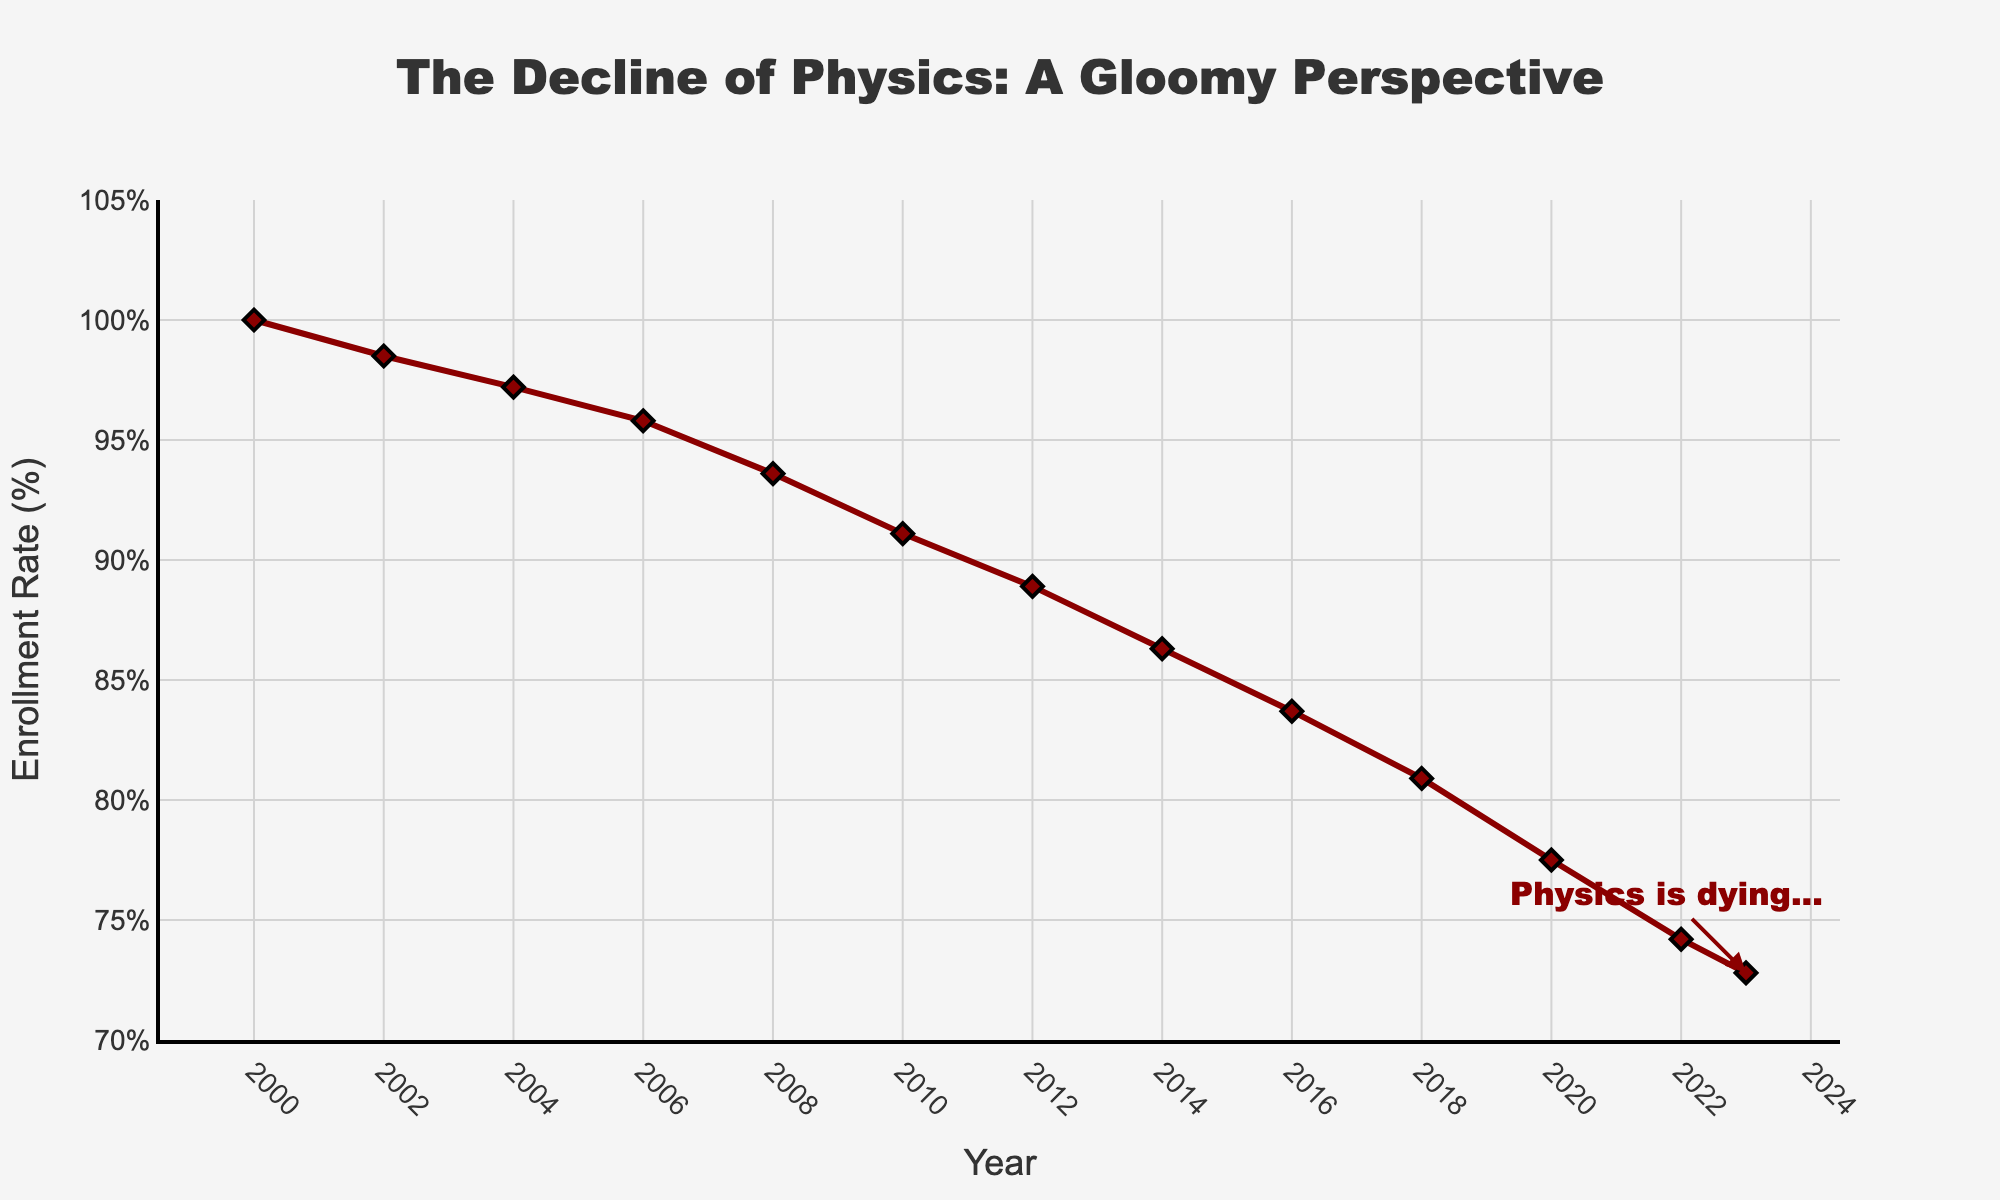What was the enrollment rate in 2000 compared to 2023? The enrollment rate in 2000 can be located at the beginning of the plotted line, while the rate for 2023 is at the end. Simply compare these two values on the y-axis. The enrollment rate was 100% in 2000 and dropped to 72.8% in 2023.
Answer: 100% vs 72.8% By how much did the enrollment rate decrease from 2008 to 2010? Locate the points for the years 2008 and 2010 on the x-axis, then see the corresponding y-values. The enrollment rates were 93.6% in 2008 and 91.1% in 2010. Subtract these values to find the decrease. 93.6% - 91.1% = 2.5%.
Answer: 2.5% Which year had the steepest year-over-year decline in enrollment rate? Examine the slope between consecutive years in the chart and identify the steepest part of the line. The steepest decline appears to be between 2020 and 2022, where enrollment drops from 77.5% to 74.2%. Calculate the difference to confirm. 77.5% - 74.2% = 3.3%.
Answer: 2020-2022 What is the overall percentage decrease in enrollment from 2000 to 2023? Subtract the enrollment rate in 2023 from that in 2000, then divide by the 2000 rate, and multiply by 100 to get the percentage decrease. (100% - 72.8%) / 100% * 100 = 27.2%.
Answer: 27.2% How does the enrollment rate in 2023 compare to the average enrollment rate from 2000 to 2023? Calculate the average enrollment rate over all the given years, then compare it to the 2023 rate. To find the average: (Sum of all annual rates from 2000 to 2023) / 13 = (100 + 98.5 + 97.2 + 95.8 + 93.6 + 91.1 + 88.9 + 86.3 + 83.7 + 80.9 + 77.5 + 74.2 + 72.8) / 13 ≈ 88.0%.
Answer: Lower Which year marks the start of the most consistent decrease in enrollment rate over multiple consecutive periods? Identify the point where the line consistently trends downwards without leveling out for multiple periods. Starting from 2006, the enrollment rate decreased continuously.
Answer: 2006 What is the median enrollment rate during 2000-2023? Arrange the enrollment values in ascending order and find the middle value. For an odd number of years (13), the median is the 7th value in the ordered list. Ordered list: 72.8, 74.2, 77.5, 80.9, 83.7, 86.3, 88.9, 91.1, 93.6, 95.8, 97.2, 98.5, 100.
Answer: 88.9% What trend does the annotation in the chart hint at? The annotation "Physics is dying..." with an arrow pointing to 2023 implies a negative outlook on the future of physics enrollment. Observing the downward trend supports this pessimistic outlook.
Answer: Negative trend During which period did the enrollment rate drop by approximately 5%? Find intervals where the difference between start and end years is close to 5%. For example, from 2008 (93.6%) to 2012 (88.9%). Difference: 93.6% - 88.9% = 4.7%, approximately 5%.
Answer: 2008-2012 